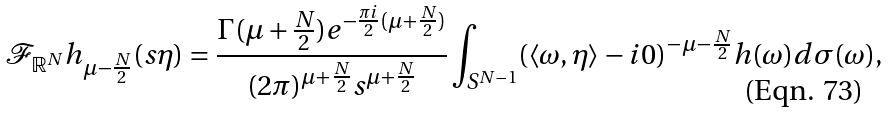<formula> <loc_0><loc_0><loc_500><loc_500>\mathcal { F } _ { \mathbb { R } ^ { N } } h _ { \mu - \frac { N } { 2 } } ( s \eta ) = \frac { \Gamma ( \mu + \frac { N } { 2 } ) e ^ { - \frac { \pi i } { 2 } ( \mu + \frac { N } { 2 } ) } } { ( 2 \pi ) ^ { \mu + \frac { N } { 2 } } s ^ { \mu + \frac { N } { 2 } } } \int _ { S ^ { N - 1 } } ( \langle \omega , \eta \rangle - i 0 ) ^ { - \mu - \frac { N } { 2 } } h ( \omega ) d \sigma ( \omega ) ,</formula> 